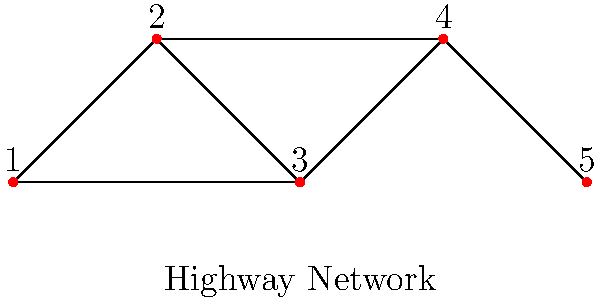As a rest stop manager, you're analyzing the connectivity of a highway network represented by the graph above. If a road closure occurs between points 2 and 3, how many different routes would still exist to travel from point 1 to point 5? Let's approach this step-by-step:

1. First, we need to identify all possible routes from point 1 to point 5 in the original graph:
   - 1 → 2 → 3 → 4 → 5
   - 1 → 2 → 5
   - 1 → 3 → 4 → 5

2. Now, we're told that the road between points 2 and 3 is closed. This eliminates the first route.

3. Let's examine the remaining routes:
   - 1 → 2 → 5 is still valid
   - 1 → 3 → 4 → 5 is still valid

4. We can see that even with the road closure, there are still two distinct routes from point 1 to point 5.

5. These routes do not share any common segments, making them completely independent paths.

Therefore, after the road closure between points 2 and 3, there would still be 2 different routes to travel from point 1 to point 5.
Answer: 2 